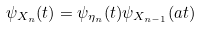<formula> <loc_0><loc_0><loc_500><loc_500>\psi _ { X _ { n } } ( t ) = \psi _ { \eta _ { n } } ( t ) \psi _ { X _ { n - 1 } } ( a t )</formula> 